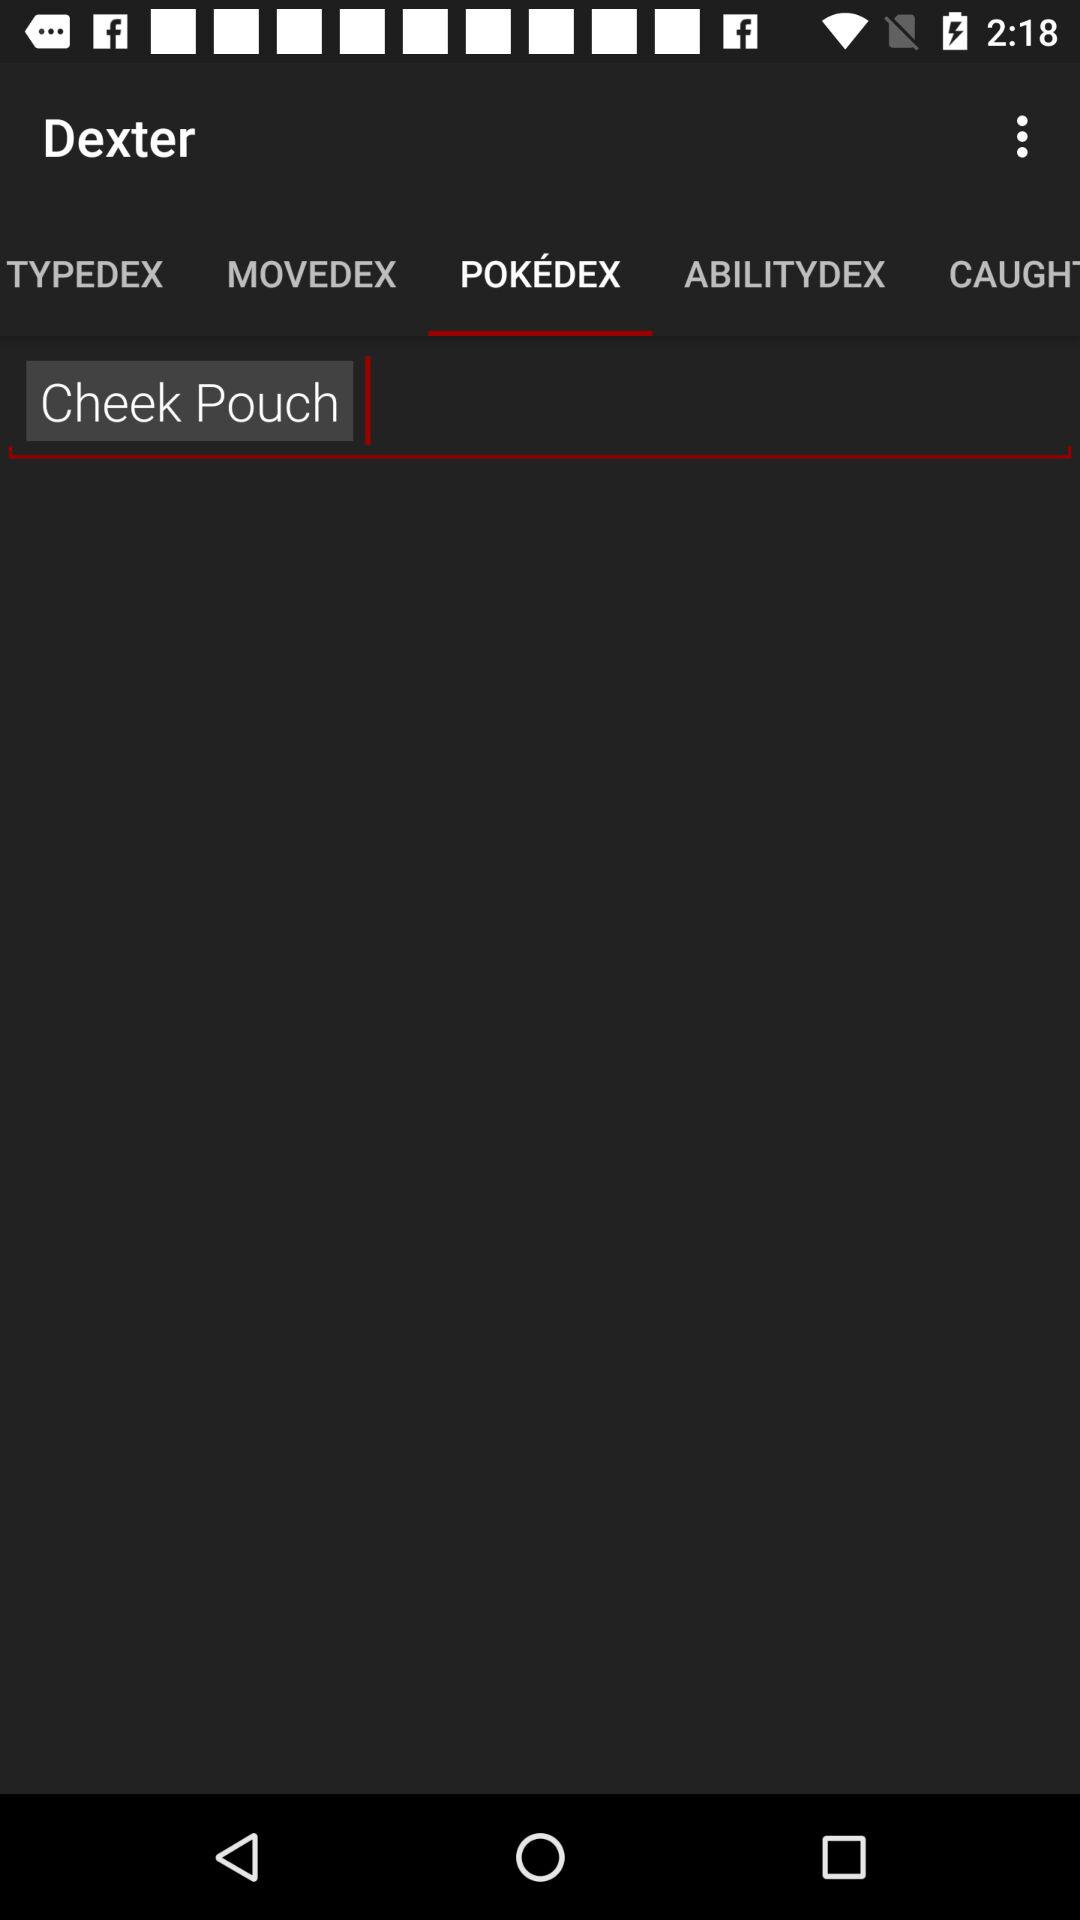Which option has been selected? The selected option is "POKÉDEX". 